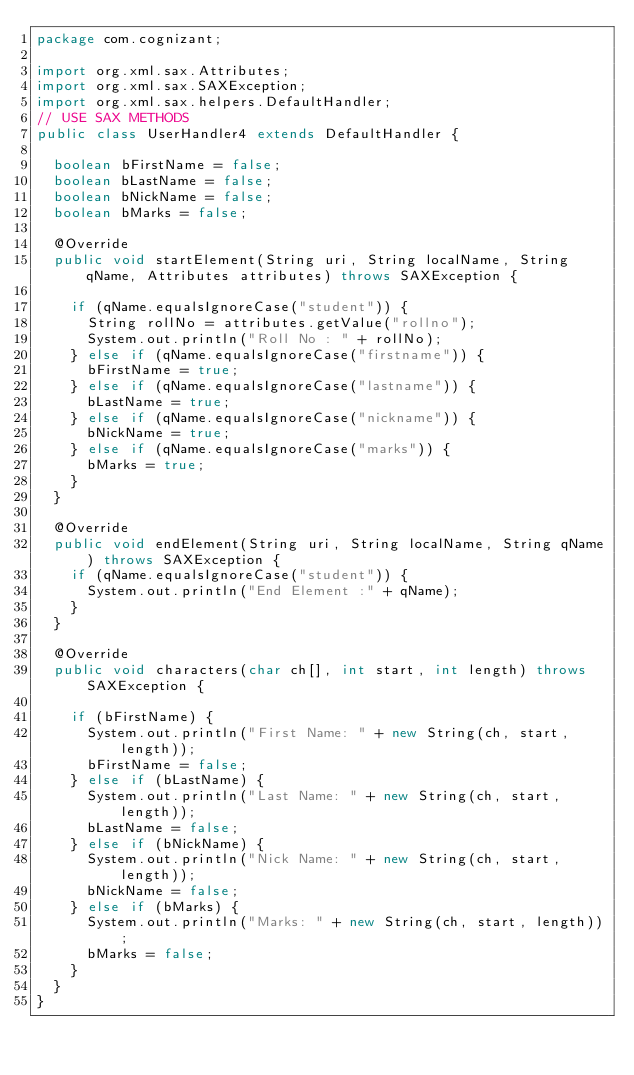Convert code to text. <code><loc_0><loc_0><loc_500><loc_500><_Java_>package com.cognizant;

import org.xml.sax.Attributes;
import org.xml.sax.SAXException;
import org.xml.sax.helpers.DefaultHandler;
// USE SAX METHODS
public class UserHandler4 extends DefaultHandler {

	boolean bFirstName = false;
	boolean bLastName = false;
	boolean bNickName = false;
	boolean bMarks = false;

	@Override
	public void startElement(String uri, String localName, String qName, Attributes attributes) throws SAXException {

		if (qName.equalsIgnoreCase("student")) {
			String rollNo = attributes.getValue("rollno");
			System.out.println("Roll No : " + rollNo);
		} else if (qName.equalsIgnoreCase("firstname")) {
			bFirstName = true;
		} else if (qName.equalsIgnoreCase("lastname")) {
			bLastName = true;
		} else if (qName.equalsIgnoreCase("nickname")) {
			bNickName = true;
		} else if (qName.equalsIgnoreCase("marks")) {
			bMarks = true;
		}
	}

	@Override
	public void endElement(String uri, String localName, String qName) throws SAXException {
		if (qName.equalsIgnoreCase("student")) {
			System.out.println("End Element :" + qName);
		}
	}

	@Override
	public void characters(char ch[], int start, int length) throws SAXException {

		if (bFirstName) {
			System.out.println("First Name: " + new String(ch, start, length));
			bFirstName = false;
		} else if (bLastName) {
			System.out.println("Last Name: " + new String(ch, start, length));
			bLastName = false;
		} else if (bNickName) {
			System.out.println("Nick Name: " + new String(ch, start, length));
			bNickName = false;
		} else if (bMarks) {
			System.out.println("Marks: " + new String(ch, start, length));
			bMarks = false;
		}
	}
}</code> 